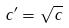Convert formula to latex. <formula><loc_0><loc_0><loc_500><loc_500>c ^ { \prime } = \sqrt { c }</formula> 